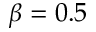Convert formula to latex. <formula><loc_0><loc_0><loc_500><loc_500>\beta = 0 . 5</formula> 